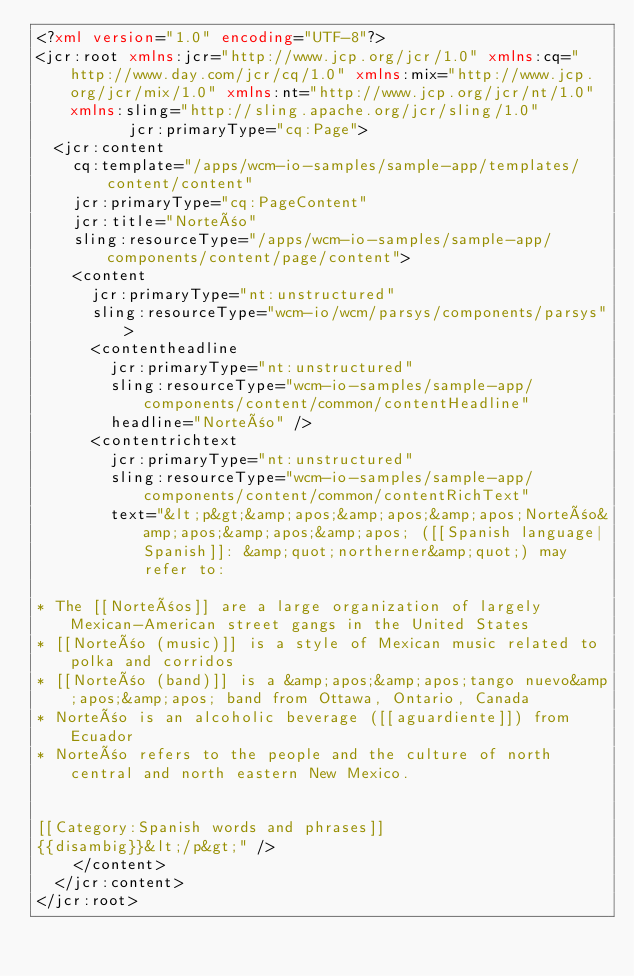Convert code to text. <code><loc_0><loc_0><loc_500><loc_500><_XML_><?xml version="1.0" encoding="UTF-8"?>
<jcr:root xmlns:jcr="http://www.jcp.org/jcr/1.0" xmlns:cq="http://www.day.com/jcr/cq/1.0" xmlns:mix="http://www.jcp.org/jcr/mix/1.0" xmlns:nt="http://www.jcp.org/jcr/nt/1.0" xmlns:sling="http://sling.apache.org/jcr/sling/1.0"
          jcr:primaryType="cq:Page">
  <jcr:content
    cq:template="/apps/wcm-io-samples/sample-app/templates/content/content"
    jcr:primaryType="cq:PageContent"
    jcr:title="Norteño"
    sling:resourceType="/apps/wcm-io-samples/sample-app/components/content/page/content">
    <content
      jcr:primaryType="nt:unstructured"
      sling:resourceType="wcm-io/wcm/parsys/components/parsys">
      <contentheadline
        jcr:primaryType="nt:unstructured"
        sling:resourceType="wcm-io-samples/sample-app/components/content/common/contentHeadline"
        headline="Norteño" />
      <contentrichtext
        jcr:primaryType="nt:unstructured"
        sling:resourceType="wcm-io-samples/sample-app/components/content/common/contentRichText"
        text="&lt;p&gt;&amp;apos;&amp;apos;&amp;apos;Norteño&amp;apos;&amp;apos;&amp;apos; ([[Spanish language|Spanish]]: &amp;quot;northerner&amp;quot;) may refer to:

* The [[Norteños]] are a large organization of largely Mexican-American street gangs in the United States
* [[Norteño (music)]] is a style of Mexican music related to polka and corridos
* [[Norteño (band)]] is a &amp;apos;&amp;apos;tango nuevo&amp;apos;&amp;apos; band from Ottawa, Ontario, Canada
* Norteño is an alcoholic beverage ([[aguardiente]]) from Ecuador
* Norteño refers to the people and the culture of north central and north eastern New Mexico.


[[Category:Spanish words and phrases]]
{{disambig}}&lt;/p&gt;" />
    </content>
  </jcr:content>
</jcr:root>
</code> 